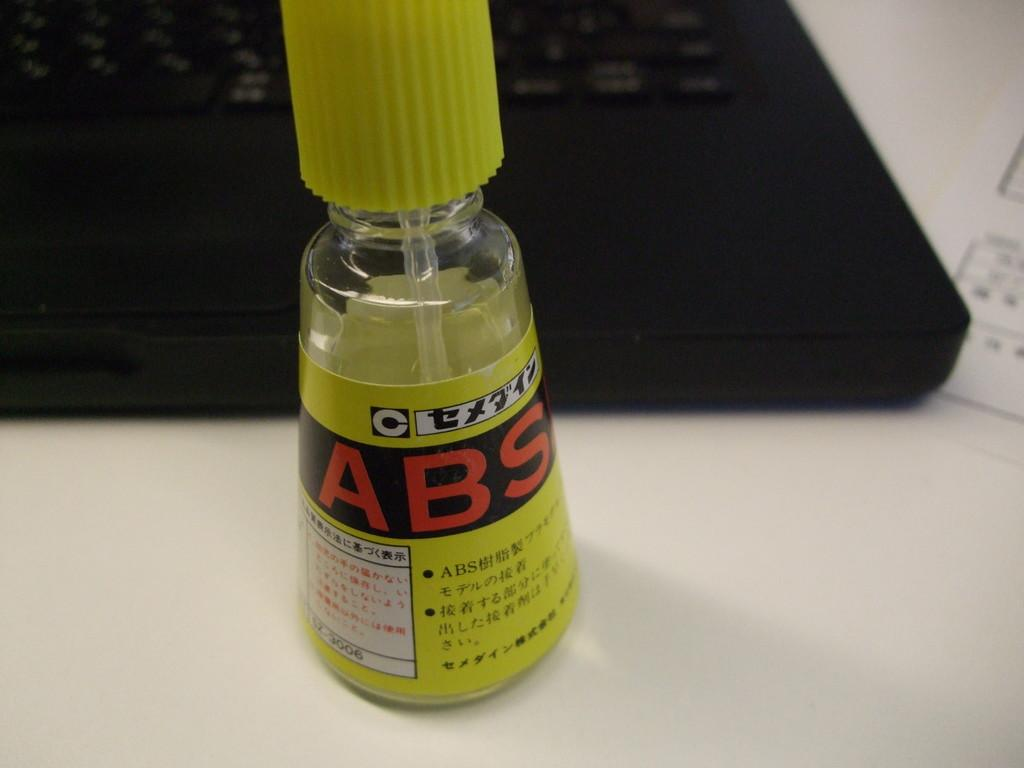What object can be seen in the image with a yellow cap? There is a bottle in the image with a yellow cap. Where is the bottle located in the image? The bottle is placed on a table. What can be seen in the background of the image? There is a keyboard in the background of the image. What is the color of the keys on the keyboard? The keys on the keyboard are black in color. How does the bottle provide support to the mark on the keyboard? The bottle does not provide support to any mark on the keyboard, as it is placed on a table and not in contact with the keyboard. 